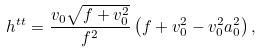<formula> <loc_0><loc_0><loc_500><loc_500>h ^ { t t } = \frac { v _ { 0 } \sqrt { f + v _ { 0 } ^ { 2 } } } { f ^ { 2 } } \left ( f + v _ { 0 } ^ { 2 } - v _ { 0 } ^ { 2 } a _ { 0 } ^ { 2 } \right ) ,</formula> 